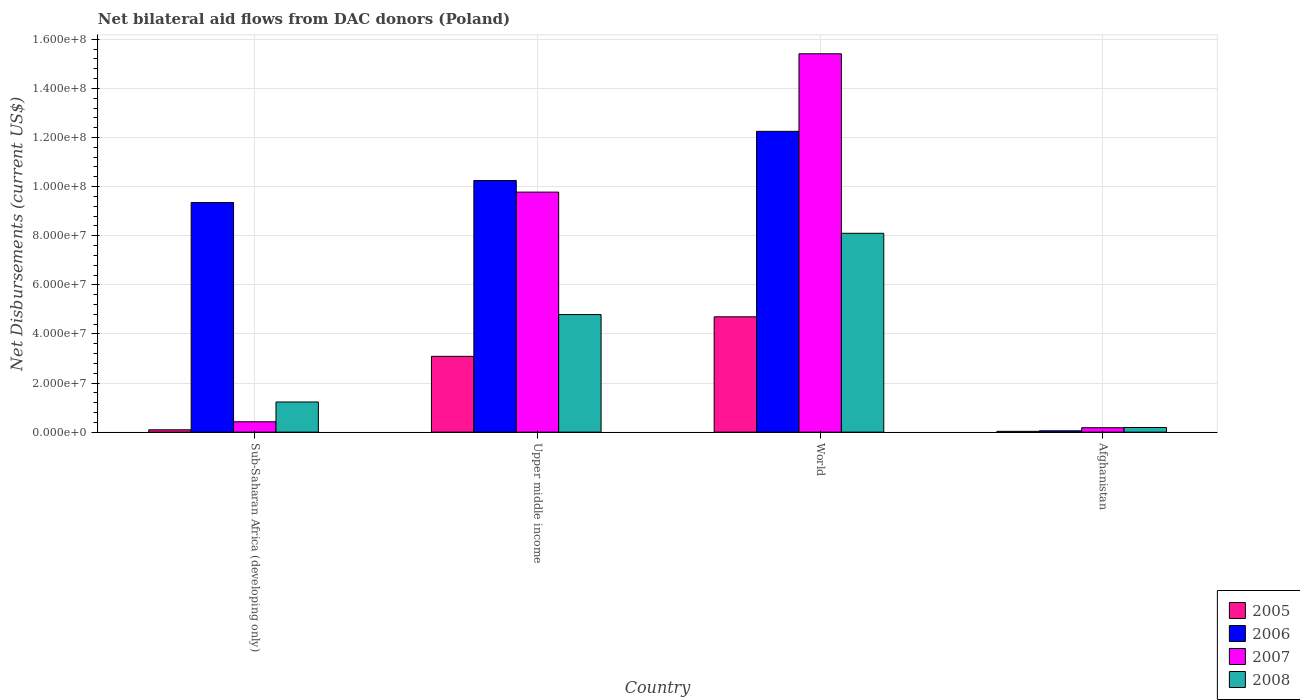How many different coloured bars are there?
Your response must be concise. 4. How many bars are there on the 3rd tick from the left?
Provide a short and direct response. 4. What is the label of the 2nd group of bars from the left?
Offer a very short reply. Upper middle income. In how many cases, is the number of bars for a given country not equal to the number of legend labels?
Give a very brief answer. 0. What is the net bilateral aid flows in 2007 in World?
Ensure brevity in your answer.  1.54e+08. Across all countries, what is the maximum net bilateral aid flows in 2006?
Your response must be concise. 1.23e+08. In which country was the net bilateral aid flows in 2005 maximum?
Keep it short and to the point. World. In which country was the net bilateral aid flows in 2008 minimum?
Offer a very short reply. Afghanistan. What is the total net bilateral aid flows in 2007 in the graph?
Provide a succinct answer. 2.58e+08. What is the difference between the net bilateral aid flows in 2008 in Upper middle income and that in World?
Ensure brevity in your answer.  -3.31e+07. What is the difference between the net bilateral aid flows in 2005 in Upper middle income and the net bilateral aid flows in 2006 in World?
Offer a very short reply. -9.17e+07. What is the average net bilateral aid flows in 2006 per country?
Give a very brief answer. 7.98e+07. What is the difference between the net bilateral aid flows of/in 2008 and net bilateral aid flows of/in 2005 in World?
Give a very brief answer. 3.40e+07. What is the ratio of the net bilateral aid flows in 2007 in Afghanistan to that in Upper middle income?
Provide a short and direct response. 0.02. Is the net bilateral aid flows in 2006 in Upper middle income less than that in World?
Your answer should be very brief. Yes. What is the difference between the highest and the second highest net bilateral aid flows in 2008?
Keep it short and to the point. 3.31e+07. What is the difference between the highest and the lowest net bilateral aid flows in 2005?
Provide a short and direct response. 4.66e+07. Is the sum of the net bilateral aid flows in 2007 in Sub-Saharan Africa (developing only) and World greater than the maximum net bilateral aid flows in 2006 across all countries?
Ensure brevity in your answer.  Yes. What does the 4th bar from the right in Upper middle income represents?
Your answer should be very brief. 2005. Are all the bars in the graph horizontal?
Provide a short and direct response. No. How many countries are there in the graph?
Your response must be concise. 4. Are the values on the major ticks of Y-axis written in scientific E-notation?
Offer a very short reply. Yes. Does the graph contain any zero values?
Your answer should be compact. No. Where does the legend appear in the graph?
Make the answer very short. Bottom right. What is the title of the graph?
Provide a succinct answer. Net bilateral aid flows from DAC donors (Poland). Does "1979" appear as one of the legend labels in the graph?
Give a very brief answer. No. What is the label or title of the X-axis?
Ensure brevity in your answer.  Country. What is the label or title of the Y-axis?
Your answer should be very brief. Net Disbursements (current US$). What is the Net Disbursements (current US$) in 2005 in Sub-Saharan Africa (developing only)?
Give a very brief answer. 9.60e+05. What is the Net Disbursements (current US$) of 2006 in Sub-Saharan Africa (developing only)?
Make the answer very short. 9.35e+07. What is the Net Disbursements (current US$) of 2007 in Sub-Saharan Africa (developing only)?
Offer a very short reply. 4.22e+06. What is the Net Disbursements (current US$) in 2008 in Sub-Saharan Africa (developing only)?
Provide a succinct answer. 1.23e+07. What is the Net Disbursements (current US$) of 2005 in Upper middle income?
Offer a terse response. 3.09e+07. What is the Net Disbursements (current US$) of 2006 in Upper middle income?
Your answer should be compact. 1.02e+08. What is the Net Disbursements (current US$) in 2007 in Upper middle income?
Make the answer very short. 9.78e+07. What is the Net Disbursements (current US$) in 2008 in Upper middle income?
Offer a very short reply. 4.79e+07. What is the Net Disbursements (current US$) in 2005 in World?
Give a very brief answer. 4.70e+07. What is the Net Disbursements (current US$) of 2006 in World?
Your answer should be compact. 1.23e+08. What is the Net Disbursements (current US$) of 2007 in World?
Give a very brief answer. 1.54e+08. What is the Net Disbursements (current US$) in 2008 in World?
Give a very brief answer. 8.10e+07. What is the Net Disbursements (current US$) in 2005 in Afghanistan?
Make the answer very short. 3.30e+05. What is the Net Disbursements (current US$) of 2007 in Afghanistan?
Make the answer very short. 1.81e+06. What is the Net Disbursements (current US$) of 2008 in Afghanistan?
Your answer should be compact. 1.89e+06. Across all countries, what is the maximum Net Disbursements (current US$) in 2005?
Your answer should be very brief. 4.70e+07. Across all countries, what is the maximum Net Disbursements (current US$) of 2006?
Offer a terse response. 1.23e+08. Across all countries, what is the maximum Net Disbursements (current US$) in 2007?
Offer a terse response. 1.54e+08. Across all countries, what is the maximum Net Disbursements (current US$) in 2008?
Make the answer very short. 8.10e+07. Across all countries, what is the minimum Net Disbursements (current US$) in 2007?
Make the answer very short. 1.81e+06. Across all countries, what is the minimum Net Disbursements (current US$) in 2008?
Offer a terse response. 1.89e+06. What is the total Net Disbursements (current US$) in 2005 in the graph?
Your response must be concise. 7.91e+07. What is the total Net Disbursements (current US$) of 2006 in the graph?
Provide a short and direct response. 3.19e+08. What is the total Net Disbursements (current US$) of 2007 in the graph?
Make the answer very short. 2.58e+08. What is the total Net Disbursements (current US$) in 2008 in the graph?
Offer a very short reply. 1.43e+08. What is the difference between the Net Disbursements (current US$) in 2005 in Sub-Saharan Africa (developing only) and that in Upper middle income?
Offer a terse response. -2.99e+07. What is the difference between the Net Disbursements (current US$) in 2006 in Sub-Saharan Africa (developing only) and that in Upper middle income?
Your answer should be compact. -8.96e+06. What is the difference between the Net Disbursements (current US$) of 2007 in Sub-Saharan Africa (developing only) and that in Upper middle income?
Your answer should be very brief. -9.36e+07. What is the difference between the Net Disbursements (current US$) in 2008 in Sub-Saharan Africa (developing only) and that in Upper middle income?
Ensure brevity in your answer.  -3.56e+07. What is the difference between the Net Disbursements (current US$) of 2005 in Sub-Saharan Africa (developing only) and that in World?
Offer a very short reply. -4.60e+07. What is the difference between the Net Disbursements (current US$) in 2006 in Sub-Saharan Africa (developing only) and that in World?
Keep it short and to the point. -2.90e+07. What is the difference between the Net Disbursements (current US$) in 2007 in Sub-Saharan Africa (developing only) and that in World?
Give a very brief answer. -1.50e+08. What is the difference between the Net Disbursements (current US$) of 2008 in Sub-Saharan Africa (developing only) and that in World?
Ensure brevity in your answer.  -6.87e+07. What is the difference between the Net Disbursements (current US$) in 2005 in Sub-Saharan Africa (developing only) and that in Afghanistan?
Your answer should be compact. 6.30e+05. What is the difference between the Net Disbursements (current US$) in 2006 in Sub-Saharan Africa (developing only) and that in Afghanistan?
Provide a short and direct response. 9.30e+07. What is the difference between the Net Disbursements (current US$) in 2007 in Sub-Saharan Africa (developing only) and that in Afghanistan?
Ensure brevity in your answer.  2.41e+06. What is the difference between the Net Disbursements (current US$) in 2008 in Sub-Saharan Africa (developing only) and that in Afghanistan?
Provide a short and direct response. 1.04e+07. What is the difference between the Net Disbursements (current US$) in 2005 in Upper middle income and that in World?
Ensure brevity in your answer.  -1.61e+07. What is the difference between the Net Disbursements (current US$) of 2006 in Upper middle income and that in World?
Give a very brief answer. -2.00e+07. What is the difference between the Net Disbursements (current US$) in 2007 in Upper middle income and that in World?
Ensure brevity in your answer.  -5.63e+07. What is the difference between the Net Disbursements (current US$) of 2008 in Upper middle income and that in World?
Provide a succinct answer. -3.31e+07. What is the difference between the Net Disbursements (current US$) of 2005 in Upper middle income and that in Afghanistan?
Give a very brief answer. 3.05e+07. What is the difference between the Net Disbursements (current US$) of 2006 in Upper middle income and that in Afghanistan?
Your answer should be very brief. 1.02e+08. What is the difference between the Net Disbursements (current US$) of 2007 in Upper middle income and that in Afghanistan?
Offer a very short reply. 9.60e+07. What is the difference between the Net Disbursements (current US$) in 2008 in Upper middle income and that in Afghanistan?
Your answer should be compact. 4.60e+07. What is the difference between the Net Disbursements (current US$) in 2005 in World and that in Afghanistan?
Your answer should be very brief. 4.66e+07. What is the difference between the Net Disbursements (current US$) of 2006 in World and that in Afghanistan?
Provide a short and direct response. 1.22e+08. What is the difference between the Net Disbursements (current US$) of 2007 in World and that in Afghanistan?
Keep it short and to the point. 1.52e+08. What is the difference between the Net Disbursements (current US$) in 2008 in World and that in Afghanistan?
Offer a very short reply. 7.91e+07. What is the difference between the Net Disbursements (current US$) in 2005 in Sub-Saharan Africa (developing only) and the Net Disbursements (current US$) in 2006 in Upper middle income?
Ensure brevity in your answer.  -1.02e+08. What is the difference between the Net Disbursements (current US$) of 2005 in Sub-Saharan Africa (developing only) and the Net Disbursements (current US$) of 2007 in Upper middle income?
Keep it short and to the point. -9.68e+07. What is the difference between the Net Disbursements (current US$) in 2005 in Sub-Saharan Africa (developing only) and the Net Disbursements (current US$) in 2008 in Upper middle income?
Provide a short and direct response. -4.69e+07. What is the difference between the Net Disbursements (current US$) in 2006 in Sub-Saharan Africa (developing only) and the Net Disbursements (current US$) in 2007 in Upper middle income?
Your answer should be very brief. -4.23e+06. What is the difference between the Net Disbursements (current US$) in 2006 in Sub-Saharan Africa (developing only) and the Net Disbursements (current US$) in 2008 in Upper middle income?
Provide a succinct answer. 4.56e+07. What is the difference between the Net Disbursements (current US$) of 2007 in Sub-Saharan Africa (developing only) and the Net Disbursements (current US$) of 2008 in Upper middle income?
Your answer should be compact. -4.37e+07. What is the difference between the Net Disbursements (current US$) in 2005 in Sub-Saharan Africa (developing only) and the Net Disbursements (current US$) in 2006 in World?
Ensure brevity in your answer.  -1.22e+08. What is the difference between the Net Disbursements (current US$) of 2005 in Sub-Saharan Africa (developing only) and the Net Disbursements (current US$) of 2007 in World?
Your answer should be compact. -1.53e+08. What is the difference between the Net Disbursements (current US$) of 2005 in Sub-Saharan Africa (developing only) and the Net Disbursements (current US$) of 2008 in World?
Offer a very short reply. -8.00e+07. What is the difference between the Net Disbursements (current US$) in 2006 in Sub-Saharan Africa (developing only) and the Net Disbursements (current US$) in 2007 in World?
Your response must be concise. -6.06e+07. What is the difference between the Net Disbursements (current US$) in 2006 in Sub-Saharan Africa (developing only) and the Net Disbursements (current US$) in 2008 in World?
Offer a terse response. 1.25e+07. What is the difference between the Net Disbursements (current US$) of 2007 in Sub-Saharan Africa (developing only) and the Net Disbursements (current US$) of 2008 in World?
Your answer should be compact. -7.68e+07. What is the difference between the Net Disbursements (current US$) in 2005 in Sub-Saharan Africa (developing only) and the Net Disbursements (current US$) in 2006 in Afghanistan?
Your response must be concise. 4.10e+05. What is the difference between the Net Disbursements (current US$) in 2005 in Sub-Saharan Africa (developing only) and the Net Disbursements (current US$) in 2007 in Afghanistan?
Your answer should be very brief. -8.50e+05. What is the difference between the Net Disbursements (current US$) in 2005 in Sub-Saharan Africa (developing only) and the Net Disbursements (current US$) in 2008 in Afghanistan?
Offer a very short reply. -9.30e+05. What is the difference between the Net Disbursements (current US$) in 2006 in Sub-Saharan Africa (developing only) and the Net Disbursements (current US$) in 2007 in Afghanistan?
Your answer should be compact. 9.17e+07. What is the difference between the Net Disbursements (current US$) in 2006 in Sub-Saharan Africa (developing only) and the Net Disbursements (current US$) in 2008 in Afghanistan?
Keep it short and to the point. 9.16e+07. What is the difference between the Net Disbursements (current US$) in 2007 in Sub-Saharan Africa (developing only) and the Net Disbursements (current US$) in 2008 in Afghanistan?
Offer a very short reply. 2.33e+06. What is the difference between the Net Disbursements (current US$) of 2005 in Upper middle income and the Net Disbursements (current US$) of 2006 in World?
Ensure brevity in your answer.  -9.17e+07. What is the difference between the Net Disbursements (current US$) in 2005 in Upper middle income and the Net Disbursements (current US$) in 2007 in World?
Offer a terse response. -1.23e+08. What is the difference between the Net Disbursements (current US$) of 2005 in Upper middle income and the Net Disbursements (current US$) of 2008 in World?
Ensure brevity in your answer.  -5.01e+07. What is the difference between the Net Disbursements (current US$) in 2006 in Upper middle income and the Net Disbursements (current US$) in 2007 in World?
Your answer should be very brief. -5.16e+07. What is the difference between the Net Disbursements (current US$) in 2006 in Upper middle income and the Net Disbursements (current US$) in 2008 in World?
Provide a short and direct response. 2.15e+07. What is the difference between the Net Disbursements (current US$) in 2007 in Upper middle income and the Net Disbursements (current US$) in 2008 in World?
Your response must be concise. 1.68e+07. What is the difference between the Net Disbursements (current US$) of 2005 in Upper middle income and the Net Disbursements (current US$) of 2006 in Afghanistan?
Offer a very short reply. 3.03e+07. What is the difference between the Net Disbursements (current US$) in 2005 in Upper middle income and the Net Disbursements (current US$) in 2007 in Afghanistan?
Ensure brevity in your answer.  2.91e+07. What is the difference between the Net Disbursements (current US$) of 2005 in Upper middle income and the Net Disbursements (current US$) of 2008 in Afghanistan?
Offer a very short reply. 2.90e+07. What is the difference between the Net Disbursements (current US$) in 2006 in Upper middle income and the Net Disbursements (current US$) in 2007 in Afghanistan?
Provide a succinct answer. 1.01e+08. What is the difference between the Net Disbursements (current US$) in 2006 in Upper middle income and the Net Disbursements (current US$) in 2008 in Afghanistan?
Offer a very short reply. 1.01e+08. What is the difference between the Net Disbursements (current US$) in 2007 in Upper middle income and the Net Disbursements (current US$) in 2008 in Afghanistan?
Your response must be concise. 9.59e+07. What is the difference between the Net Disbursements (current US$) in 2005 in World and the Net Disbursements (current US$) in 2006 in Afghanistan?
Make the answer very short. 4.64e+07. What is the difference between the Net Disbursements (current US$) in 2005 in World and the Net Disbursements (current US$) in 2007 in Afghanistan?
Give a very brief answer. 4.52e+07. What is the difference between the Net Disbursements (current US$) of 2005 in World and the Net Disbursements (current US$) of 2008 in Afghanistan?
Keep it short and to the point. 4.51e+07. What is the difference between the Net Disbursements (current US$) of 2006 in World and the Net Disbursements (current US$) of 2007 in Afghanistan?
Make the answer very short. 1.21e+08. What is the difference between the Net Disbursements (current US$) in 2006 in World and the Net Disbursements (current US$) in 2008 in Afghanistan?
Offer a very short reply. 1.21e+08. What is the difference between the Net Disbursements (current US$) of 2007 in World and the Net Disbursements (current US$) of 2008 in Afghanistan?
Provide a short and direct response. 1.52e+08. What is the average Net Disbursements (current US$) of 2005 per country?
Give a very brief answer. 1.98e+07. What is the average Net Disbursements (current US$) of 2006 per country?
Offer a very short reply. 7.98e+07. What is the average Net Disbursements (current US$) of 2007 per country?
Your response must be concise. 6.45e+07. What is the average Net Disbursements (current US$) of 2008 per country?
Your answer should be compact. 3.58e+07. What is the difference between the Net Disbursements (current US$) of 2005 and Net Disbursements (current US$) of 2006 in Sub-Saharan Africa (developing only)?
Offer a terse response. -9.26e+07. What is the difference between the Net Disbursements (current US$) of 2005 and Net Disbursements (current US$) of 2007 in Sub-Saharan Africa (developing only)?
Give a very brief answer. -3.26e+06. What is the difference between the Net Disbursements (current US$) in 2005 and Net Disbursements (current US$) in 2008 in Sub-Saharan Africa (developing only)?
Your response must be concise. -1.13e+07. What is the difference between the Net Disbursements (current US$) in 2006 and Net Disbursements (current US$) in 2007 in Sub-Saharan Africa (developing only)?
Offer a very short reply. 8.93e+07. What is the difference between the Net Disbursements (current US$) of 2006 and Net Disbursements (current US$) of 2008 in Sub-Saharan Africa (developing only)?
Offer a terse response. 8.12e+07. What is the difference between the Net Disbursements (current US$) in 2007 and Net Disbursements (current US$) in 2008 in Sub-Saharan Africa (developing only)?
Ensure brevity in your answer.  -8.07e+06. What is the difference between the Net Disbursements (current US$) of 2005 and Net Disbursements (current US$) of 2006 in Upper middle income?
Provide a succinct answer. -7.16e+07. What is the difference between the Net Disbursements (current US$) of 2005 and Net Disbursements (current US$) of 2007 in Upper middle income?
Make the answer very short. -6.69e+07. What is the difference between the Net Disbursements (current US$) in 2005 and Net Disbursements (current US$) in 2008 in Upper middle income?
Give a very brief answer. -1.70e+07. What is the difference between the Net Disbursements (current US$) in 2006 and Net Disbursements (current US$) in 2007 in Upper middle income?
Provide a short and direct response. 4.73e+06. What is the difference between the Net Disbursements (current US$) of 2006 and Net Disbursements (current US$) of 2008 in Upper middle income?
Offer a very short reply. 5.46e+07. What is the difference between the Net Disbursements (current US$) of 2007 and Net Disbursements (current US$) of 2008 in Upper middle income?
Your answer should be very brief. 4.99e+07. What is the difference between the Net Disbursements (current US$) in 2005 and Net Disbursements (current US$) in 2006 in World?
Your answer should be very brief. -7.56e+07. What is the difference between the Net Disbursements (current US$) of 2005 and Net Disbursements (current US$) of 2007 in World?
Make the answer very short. -1.07e+08. What is the difference between the Net Disbursements (current US$) of 2005 and Net Disbursements (current US$) of 2008 in World?
Provide a succinct answer. -3.40e+07. What is the difference between the Net Disbursements (current US$) of 2006 and Net Disbursements (current US$) of 2007 in World?
Your response must be concise. -3.16e+07. What is the difference between the Net Disbursements (current US$) of 2006 and Net Disbursements (current US$) of 2008 in World?
Keep it short and to the point. 4.15e+07. What is the difference between the Net Disbursements (current US$) in 2007 and Net Disbursements (current US$) in 2008 in World?
Offer a terse response. 7.31e+07. What is the difference between the Net Disbursements (current US$) of 2005 and Net Disbursements (current US$) of 2006 in Afghanistan?
Your answer should be compact. -2.20e+05. What is the difference between the Net Disbursements (current US$) in 2005 and Net Disbursements (current US$) in 2007 in Afghanistan?
Your answer should be compact. -1.48e+06. What is the difference between the Net Disbursements (current US$) of 2005 and Net Disbursements (current US$) of 2008 in Afghanistan?
Give a very brief answer. -1.56e+06. What is the difference between the Net Disbursements (current US$) in 2006 and Net Disbursements (current US$) in 2007 in Afghanistan?
Provide a succinct answer. -1.26e+06. What is the difference between the Net Disbursements (current US$) in 2006 and Net Disbursements (current US$) in 2008 in Afghanistan?
Offer a very short reply. -1.34e+06. What is the ratio of the Net Disbursements (current US$) of 2005 in Sub-Saharan Africa (developing only) to that in Upper middle income?
Your response must be concise. 0.03. What is the ratio of the Net Disbursements (current US$) in 2006 in Sub-Saharan Africa (developing only) to that in Upper middle income?
Provide a short and direct response. 0.91. What is the ratio of the Net Disbursements (current US$) in 2007 in Sub-Saharan Africa (developing only) to that in Upper middle income?
Make the answer very short. 0.04. What is the ratio of the Net Disbursements (current US$) of 2008 in Sub-Saharan Africa (developing only) to that in Upper middle income?
Give a very brief answer. 0.26. What is the ratio of the Net Disbursements (current US$) in 2005 in Sub-Saharan Africa (developing only) to that in World?
Provide a short and direct response. 0.02. What is the ratio of the Net Disbursements (current US$) in 2006 in Sub-Saharan Africa (developing only) to that in World?
Provide a succinct answer. 0.76. What is the ratio of the Net Disbursements (current US$) of 2007 in Sub-Saharan Africa (developing only) to that in World?
Make the answer very short. 0.03. What is the ratio of the Net Disbursements (current US$) of 2008 in Sub-Saharan Africa (developing only) to that in World?
Your answer should be very brief. 0.15. What is the ratio of the Net Disbursements (current US$) of 2005 in Sub-Saharan Africa (developing only) to that in Afghanistan?
Offer a terse response. 2.91. What is the ratio of the Net Disbursements (current US$) of 2006 in Sub-Saharan Africa (developing only) to that in Afghanistan?
Provide a succinct answer. 170.07. What is the ratio of the Net Disbursements (current US$) in 2007 in Sub-Saharan Africa (developing only) to that in Afghanistan?
Give a very brief answer. 2.33. What is the ratio of the Net Disbursements (current US$) in 2008 in Sub-Saharan Africa (developing only) to that in Afghanistan?
Ensure brevity in your answer.  6.5. What is the ratio of the Net Disbursements (current US$) in 2005 in Upper middle income to that in World?
Keep it short and to the point. 0.66. What is the ratio of the Net Disbursements (current US$) in 2006 in Upper middle income to that in World?
Give a very brief answer. 0.84. What is the ratio of the Net Disbursements (current US$) in 2007 in Upper middle income to that in World?
Offer a very short reply. 0.63. What is the ratio of the Net Disbursements (current US$) in 2008 in Upper middle income to that in World?
Provide a short and direct response. 0.59. What is the ratio of the Net Disbursements (current US$) of 2005 in Upper middle income to that in Afghanistan?
Give a very brief answer. 93.55. What is the ratio of the Net Disbursements (current US$) of 2006 in Upper middle income to that in Afghanistan?
Make the answer very short. 186.36. What is the ratio of the Net Disbursements (current US$) in 2007 in Upper middle income to that in Afghanistan?
Ensure brevity in your answer.  54.02. What is the ratio of the Net Disbursements (current US$) of 2008 in Upper middle income to that in Afghanistan?
Your answer should be compact. 25.34. What is the ratio of the Net Disbursements (current US$) in 2005 in World to that in Afghanistan?
Keep it short and to the point. 142.36. What is the ratio of the Net Disbursements (current US$) in 2006 in World to that in Afghanistan?
Provide a short and direct response. 222.78. What is the ratio of the Net Disbursements (current US$) of 2007 in World to that in Afghanistan?
Keep it short and to the point. 85.14. What is the ratio of the Net Disbursements (current US$) of 2008 in World to that in Afghanistan?
Provide a short and direct response. 42.86. What is the difference between the highest and the second highest Net Disbursements (current US$) of 2005?
Provide a short and direct response. 1.61e+07. What is the difference between the highest and the second highest Net Disbursements (current US$) in 2006?
Give a very brief answer. 2.00e+07. What is the difference between the highest and the second highest Net Disbursements (current US$) of 2007?
Offer a terse response. 5.63e+07. What is the difference between the highest and the second highest Net Disbursements (current US$) in 2008?
Your response must be concise. 3.31e+07. What is the difference between the highest and the lowest Net Disbursements (current US$) in 2005?
Your response must be concise. 4.66e+07. What is the difference between the highest and the lowest Net Disbursements (current US$) of 2006?
Your answer should be compact. 1.22e+08. What is the difference between the highest and the lowest Net Disbursements (current US$) of 2007?
Offer a very short reply. 1.52e+08. What is the difference between the highest and the lowest Net Disbursements (current US$) of 2008?
Offer a terse response. 7.91e+07. 